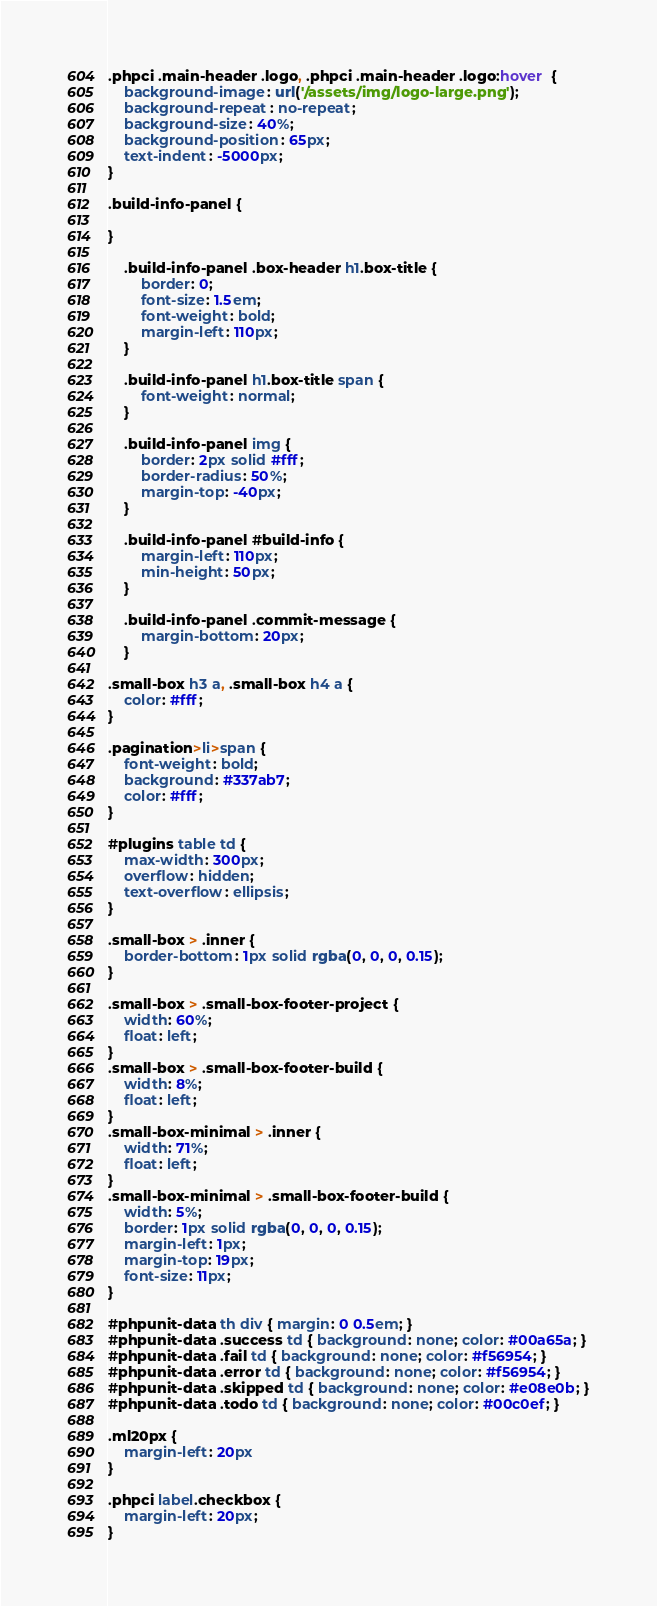Convert code to text. <code><loc_0><loc_0><loc_500><loc_500><_CSS_>.phpci .main-header .logo, .phpci .main-header .logo:hover  {
    background-image: url('/assets/img/logo-large.png');
    background-repeat: no-repeat;
    background-size: 40%;
    background-position: 65px;
    text-indent: -5000px;
}

.build-info-panel {

}

    .build-info-panel .box-header h1.box-title {
        border: 0;
        font-size: 1.5em;
        font-weight: bold;
        margin-left: 110px;
    }

    .build-info-panel h1.box-title span {
        font-weight: normal;
    }

    .build-info-panel img {
        border: 2px solid #fff;
        border-radius: 50%;
        margin-top: -40px;
    }

    .build-info-panel #build-info {
        margin-left: 110px;
        min-height: 50px;
    }

    .build-info-panel .commit-message {
        margin-bottom: 20px;
    }

.small-box h3 a, .small-box h4 a {
    color: #fff;
}

.pagination>li>span {
    font-weight: bold;
    background: #337ab7;
    color: #fff;
}

#plugins table td {
    max-width: 300px;
    overflow: hidden;
    text-overflow: ellipsis;
}

.small-box > .inner {
    border-bottom: 1px solid rgba(0, 0, 0, 0.15);
}

.small-box > .small-box-footer-project {
    width: 60%;
    float: left;
}
.small-box > .small-box-footer-build {
    width: 8%;
    float: left;
}
.small-box-minimal > .inner {
    width: 71%;
    float: left;
}
.small-box-minimal > .small-box-footer-build {
    width: 5%;
    border: 1px solid rgba(0, 0, 0, 0.15);
    margin-left: 1px;
    margin-top: 19px;
    font-size: 11px;
}

#phpunit-data th div { margin: 0 0.5em; }
#phpunit-data .success td { background: none; color: #00a65a; }
#phpunit-data .fail td { background: none; color: #f56954; }
#phpunit-data .error td { background: none; color: #f56954; }
#phpunit-data .skipped td { background: none; color: #e08e0b; }
#phpunit-data .todo td { background: none; color: #00c0ef; }

.ml20px {
    margin-left: 20px
}

.phpci label.checkbox {
    margin-left: 20px;
}</code> 